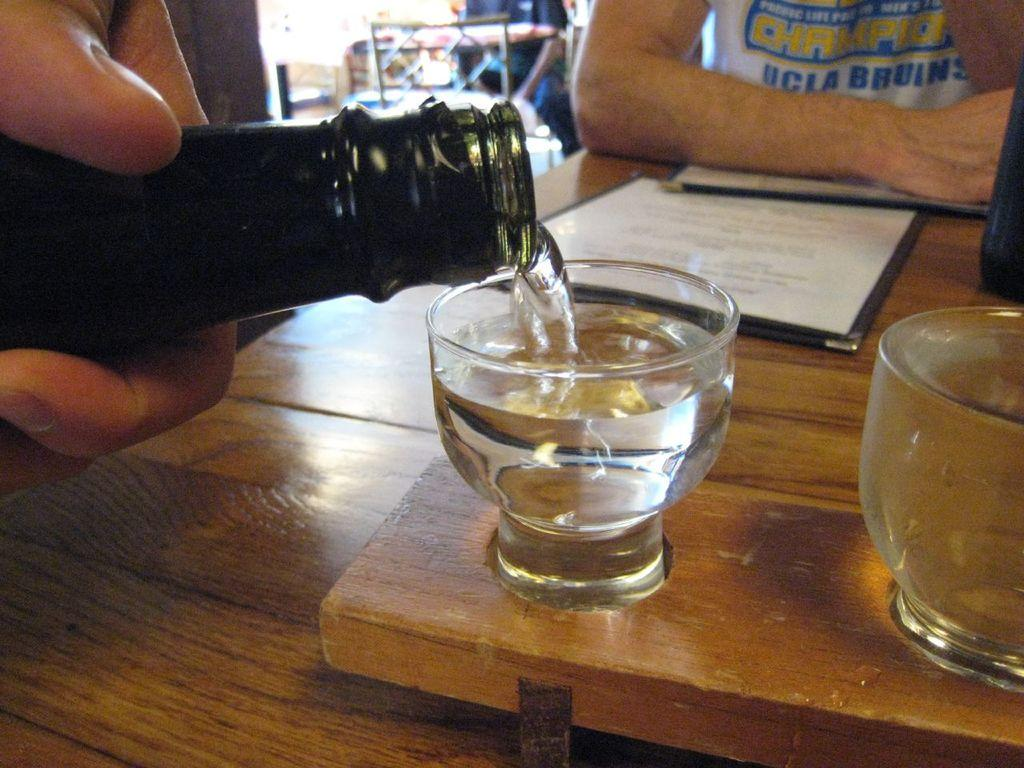<image>
Describe the image concisely. A person is in a UCLA shirt where a drink is being poured. 